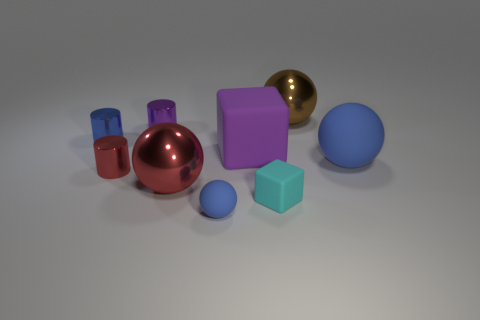Subtract all brown cylinders. How many blue balls are left? 2 Subtract all tiny blue cylinders. How many cylinders are left? 2 Subtract all brown balls. How many balls are left? 3 Subtract all balls. How many objects are left? 5 Subtract all yellow balls. Subtract all gray cubes. How many balls are left? 4 Add 4 large brown balls. How many large brown balls exist? 5 Subtract 0 gray spheres. How many objects are left? 9 Subtract all green rubber cylinders. Subtract all tiny purple cylinders. How many objects are left? 8 Add 1 tiny cylinders. How many tiny cylinders are left? 4 